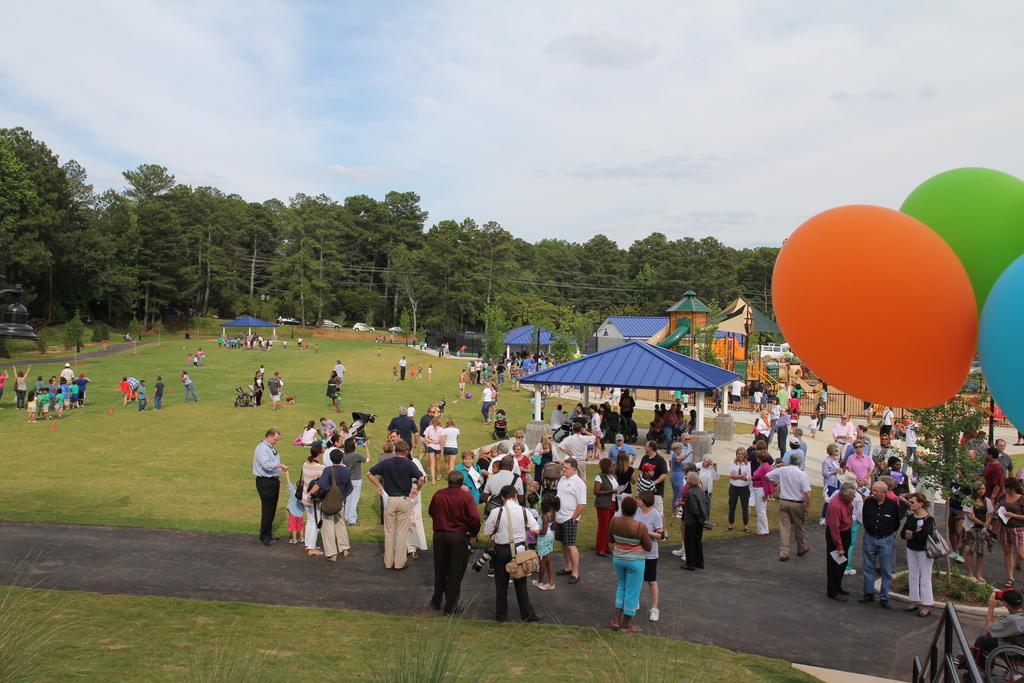In one or two sentences, can you explain what this image depicts? There are few persons standing on the road and grass and among them few are carrying bags on their shoulders. In the background there are buildings,trees,poles,gazebo,fence and clouds in the sky. On the right there are balloons,tree and a person is sitting on a wheel chair on the road and other objects. 